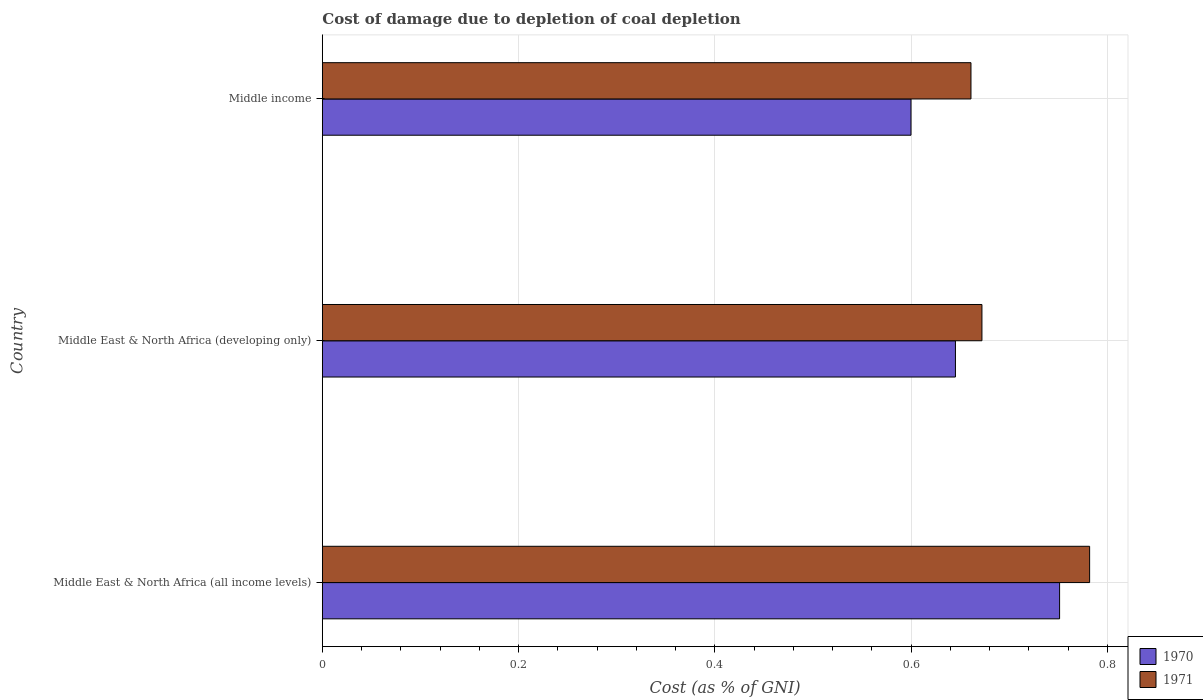How many different coloured bars are there?
Ensure brevity in your answer.  2. How many groups of bars are there?
Provide a succinct answer. 3. Are the number of bars on each tick of the Y-axis equal?
Make the answer very short. Yes. How many bars are there on the 1st tick from the bottom?
Make the answer very short. 2. What is the label of the 1st group of bars from the top?
Your answer should be very brief. Middle income. In how many cases, is the number of bars for a given country not equal to the number of legend labels?
Give a very brief answer. 0. What is the cost of damage caused due to coal depletion in 1970 in Middle East & North Africa (developing only)?
Offer a terse response. 0.65. Across all countries, what is the maximum cost of damage caused due to coal depletion in 1970?
Ensure brevity in your answer.  0.75. Across all countries, what is the minimum cost of damage caused due to coal depletion in 1970?
Offer a terse response. 0.6. In which country was the cost of damage caused due to coal depletion in 1971 maximum?
Your answer should be compact. Middle East & North Africa (all income levels). In which country was the cost of damage caused due to coal depletion in 1971 minimum?
Provide a succinct answer. Middle income. What is the total cost of damage caused due to coal depletion in 1970 in the graph?
Your answer should be compact. 2. What is the difference between the cost of damage caused due to coal depletion in 1970 in Middle East & North Africa (all income levels) and that in Middle East & North Africa (developing only)?
Ensure brevity in your answer.  0.11. What is the difference between the cost of damage caused due to coal depletion in 1971 in Middle East & North Africa (all income levels) and the cost of damage caused due to coal depletion in 1970 in Middle East & North Africa (developing only)?
Make the answer very short. 0.14. What is the average cost of damage caused due to coal depletion in 1970 per country?
Provide a succinct answer. 0.67. What is the difference between the cost of damage caused due to coal depletion in 1970 and cost of damage caused due to coal depletion in 1971 in Middle income?
Your answer should be compact. -0.06. What is the ratio of the cost of damage caused due to coal depletion in 1970 in Middle East & North Africa (all income levels) to that in Middle income?
Offer a terse response. 1.25. Is the difference between the cost of damage caused due to coal depletion in 1970 in Middle East & North Africa (all income levels) and Middle income greater than the difference between the cost of damage caused due to coal depletion in 1971 in Middle East & North Africa (all income levels) and Middle income?
Provide a short and direct response. Yes. What is the difference between the highest and the second highest cost of damage caused due to coal depletion in 1970?
Ensure brevity in your answer.  0.11. What is the difference between the highest and the lowest cost of damage caused due to coal depletion in 1970?
Keep it short and to the point. 0.15. Is the sum of the cost of damage caused due to coal depletion in 1970 in Middle East & North Africa (all income levels) and Middle income greater than the maximum cost of damage caused due to coal depletion in 1971 across all countries?
Offer a terse response. Yes. What does the 1st bar from the top in Middle East & North Africa (all income levels) represents?
Offer a terse response. 1971. Are all the bars in the graph horizontal?
Give a very brief answer. Yes. What is the difference between two consecutive major ticks on the X-axis?
Your response must be concise. 0.2. Does the graph contain any zero values?
Offer a very short reply. No. Where does the legend appear in the graph?
Keep it short and to the point. Bottom right. How many legend labels are there?
Your answer should be very brief. 2. How are the legend labels stacked?
Your response must be concise. Vertical. What is the title of the graph?
Provide a short and direct response. Cost of damage due to depletion of coal depletion. What is the label or title of the X-axis?
Make the answer very short. Cost (as % of GNI). What is the label or title of the Y-axis?
Make the answer very short. Country. What is the Cost (as % of GNI) of 1970 in Middle East & North Africa (all income levels)?
Provide a short and direct response. 0.75. What is the Cost (as % of GNI) of 1971 in Middle East & North Africa (all income levels)?
Ensure brevity in your answer.  0.78. What is the Cost (as % of GNI) in 1970 in Middle East & North Africa (developing only)?
Offer a very short reply. 0.65. What is the Cost (as % of GNI) of 1971 in Middle East & North Africa (developing only)?
Your answer should be compact. 0.67. What is the Cost (as % of GNI) in 1970 in Middle income?
Provide a succinct answer. 0.6. What is the Cost (as % of GNI) of 1971 in Middle income?
Offer a terse response. 0.66. Across all countries, what is the maximum Cost (as % of GNI) in 1970?
Keep it short and to the point. 0.75. Across all countries, what is the maximum Cost (as % of GNI) of 1971?
Provide a succinct answer. 0.78. Across all countries, what is the minimum Cost (as % of GNI) in 1970?
Your answer should be compact. 0.6. Across all countries, what is the minimum Cost (as % of GNI) in 1971?
Ensure brevity in your answer.  0.66. What is the total Cost (as % of GNI) in 1970 in the graph?
Provide a short and direct response. 2. What is the total Cost (as % of GNI) of 1971 in the graph?
Offer a terse response. 2.12. What is the difference between the Cost (as % of GNI) in 1970 in Middle East & North Africa (all income levels) and that in Middle East & North Africa (developing only)?
Provide a succinct answer. 0.11. What is the difference between the Cost (as % of GNI) in 1971 in Middle East & North Africa (all income levels) and that in Middle East & North Africa (developing only)?
Your answer should be very brief. 0.11. What is the difference between the Cost (as % of GNI) of 1970 in Middle East & North Africa (all income levels) and that in Middle income?
Offer a very short reply. 0.15. What is the difference between the Cost (as % of GNI) of 1971 in Middle East & North Africa (all income levels) and that in Middle income?
Offer a very short reply. 0.12. What is the difference between the Cost (as % of GNI) of 1970 in Middle East & North Africa (developing only) and that in Middle income?
Your answer should be very brief. 0.05. What is the difference between the Cost (as % of GNI) in 1971 in Middle East & North Africa (developing only) and that in Middle income?
Offer a very short reply. 0.01. What is the difference between the Cost (as % of GNI) of 1970 in Middle East & North Africa (all income levels) and the Cost (as % of GNI) of 1971 in Middle East & North Africa (developing only)?
Keep it short and to the point. 0.08. What is the difference between the Cost (as % of GNI) in 1970 in Middle East & North Africa (all income levels) and the Cost (as % of GNI) in 1971 in Middle income?
Your response must be concise. 0.09. What is the difference between the Cost (as % of GNI) in 1970 in Middle East & North Africa (developing only) and the Cost (as % of GNI) in 1971 in Middle income?
Your answer should be very brief. -0.02. What is the average Cost (as % of GNI) of 1970 per country?
Ensure brevity in your answer.  0.67. What is the average Cost (as % of GNI) of 1971 per country?
Ensure brevity in your answer.  0.71. What is the difference between the Cost (as % of GNI) of 1970 and Cost (as % of GNI) of 1971 in Middle East & North Africa (all income levels)?
Provide a succinct answer. -0.03. What is the difference between the Cost (as % of GNI) in 1970 and Cost (as % of GNI) in 1971 in Middle East & North Africa (developing only)?
Ensure brevity in your answer.  -0.03. What is the difference between the Cost (as % of GNI) in 1970 and Cost (as % of GNI) in 1971 in Middle income?
Provide a short and direct response. -0.06. What is the ratio of the Cost (as % of GNI) of 1970 in Middle East & North Africa (all income levels) to that in Middle East & North Africa (developing only)?
Your answer should be very brief. 1.16. What is the ratio of the Cost (as % of GNI) of 1971 in Middle East & North Africa (all income levels) to that in Middle East & North Africa (developing only)?
Your answer should be compact. 1.16. What is the ratio of the Cost (as % of GNI) of 1970 in Middle East & North Africa (all income levels) to that in Middle income?
Offer a very short reply. 1.25. What is the ratio of the Cost (as % of GNI) in 1971 in Middle East & North Africa (all income levels) to that in Middle income?
Your response must be concise. 1.18. What is the ratio of the Cost (as % of GNI) in 1970 in Middle East & North Africa (developing only) to that in Middle income?
Your response must be concise. 1.08. What is the ratio of the Cost (as % of GNI) in 1971 in Middle East & North Africa (developing only) to that in Middle income?
Give a very brief answer. 1.02. What is the difference between the highest and the second highest Cost (as % of GNI) of 1970?
Give a very brief answer. 0.11. What is the difference between the highest and the second highest Cost (as % of GNI) in 1971?
Provide a short and direct response. 0.11. What is the difference between the highest and the lowest Cost (as % of GNI) in 1970?
Provide a succinct answer. 0.15. What is the difference between the highest and the lowest Cost (as % of GNI) of 1971?
Provide a short and direct response. 0.12. 